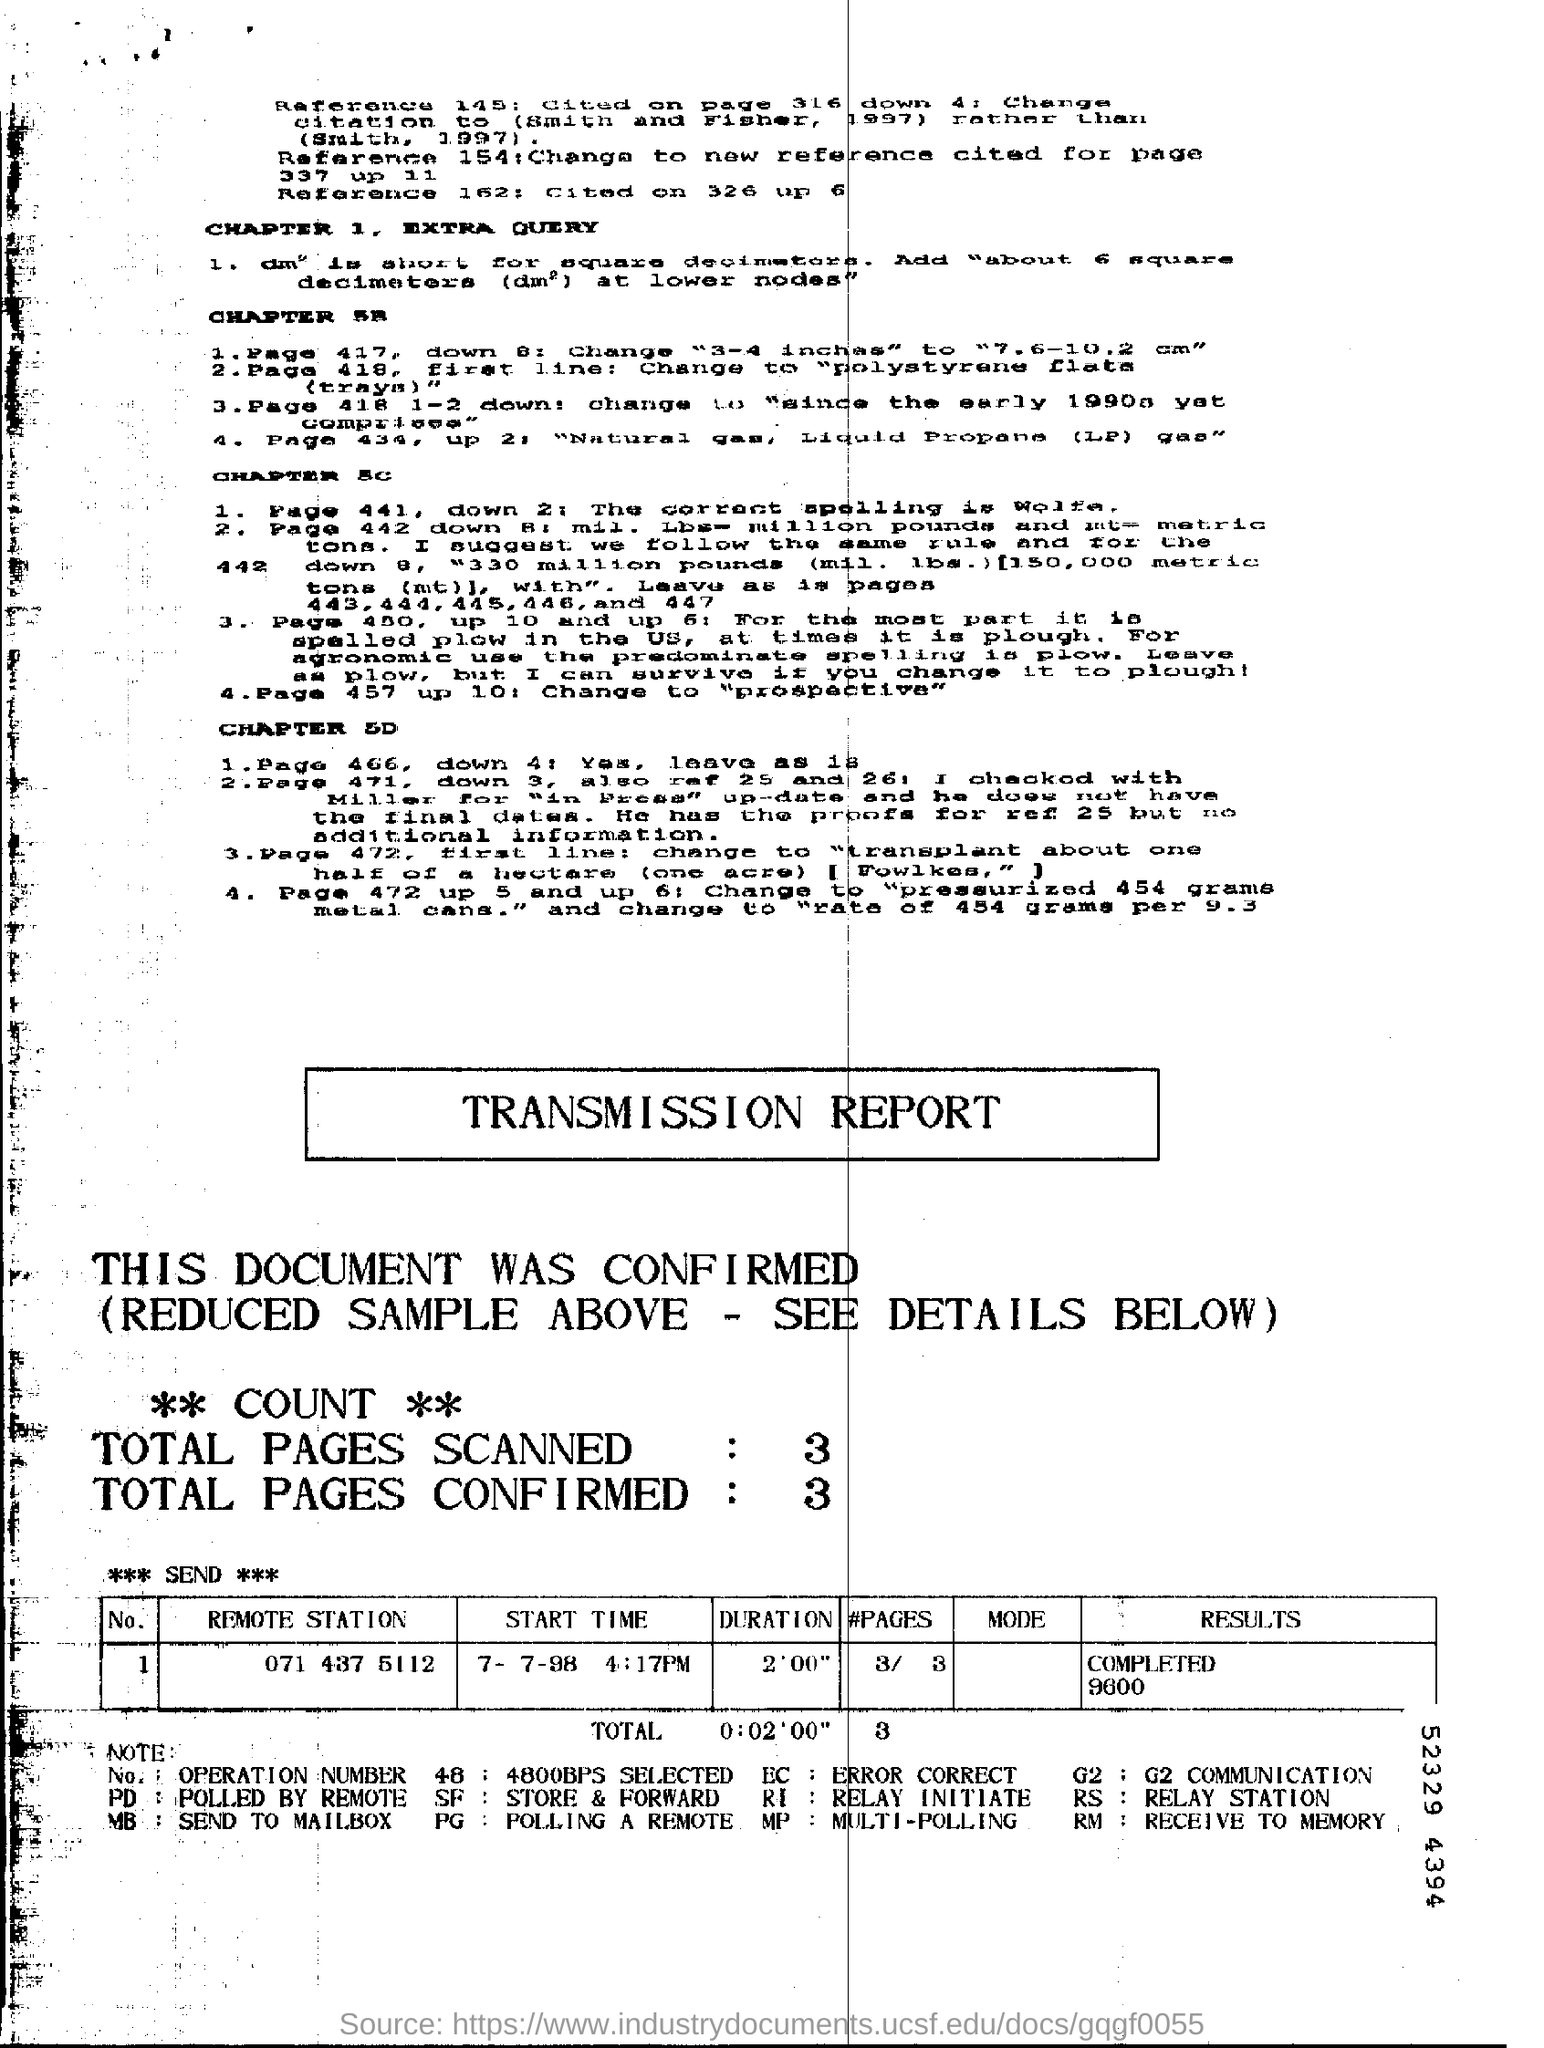How many PAGES SCANNED in TOTAL
Provide a short and direct response. 3. How many PAGES CONFIRMED in TOTAL
Ensure brevity in your answer.  3. 